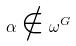Convert formula to latex. <formula><loc_0><loc_0><loc_500><loc_500>\alpha \notin \omega ^ { G }</formula> 